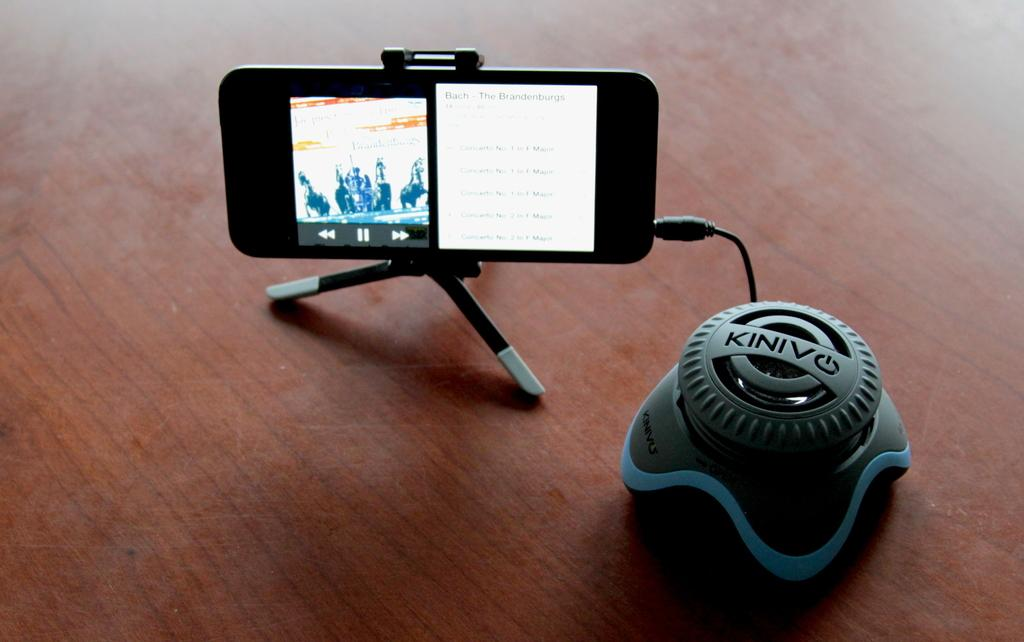What device is placed on a stand in the image? There is a mobile phone on a stand in the image. What type of surface is the electronic gadget placed on? The electronic gadget is placed on a brown color table in the image. What type of skate is visible on the table in the image? There is no skate present in the image; it only features a mobile phone on a stand and an electronic gadget on a brown color table. How many bricks can be seen supporting the table in the image? There are no bricks visible in the image; the table is not supported by bricks. 